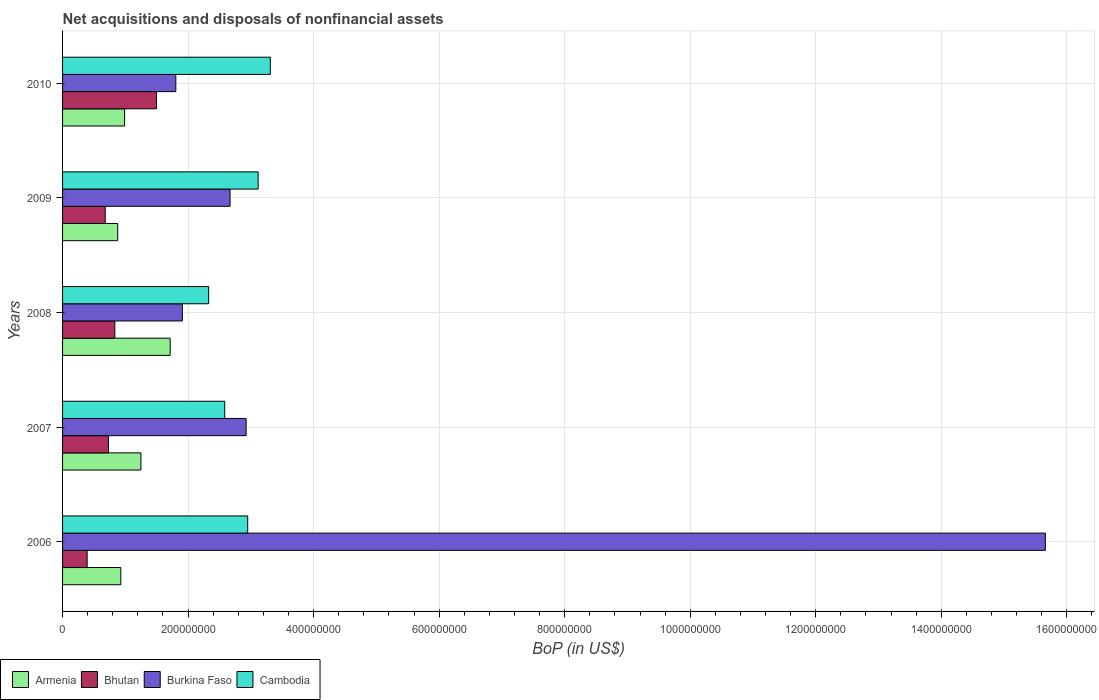How many groups of bars are there?
Make the answer very short. 5. Are the number of bars per tick equal to the number of legend labels?
Ensure brevity in your answer.  Yes. Are the number of bars on each tick of the Y-axis equal?
Provide a short and direct response. Yes. How many bars are there on the 4th tick from the bottom?
Your response must be concise. 4. What is the Balance of Payments in Cambodia in 2007?
Your response must be concise. 2.58e+08. Across all years, what is the maximum Balance of Payments in Bhutan?
Offer a very short reply. 1.50e+08. Across all years, what is the minimum Balance of Payments in Cambodia?
Provide a succinct answer. 2.33e+08. In which year was the Balance of Payments in Bhutan minimum?
Your answer should be very brief. 2006. What is the total Balance of Payments in Bhutan in the graph?
Give a very brief answer. 4.13e+08. What is the difference between the Balance of Payments in Burkina Faso in 2007 and that in 2010?
Your answer should be very brief. 1.12e+08. What is the difference between the Balance of Payments in Cambodia in 2006 and the Balance of Payments in Burkina Faso in 2008?
Offer a very short reply. 1.04e+08. What is the average Balance of Payments in Bhutan per year?
Provide a short and direct response. 8.26e+07. In the year 2010, what is the difference between the Balance of Payments in Burkina Faso and Balance of Payments in Cambodia?
Keep it short and to the point. -1.51e+08. What is the ratio of the Balance of Payments in Bhutan in 2008 to that in 2009?
Your response must be concise. 1.23. Is the difference between the Balance of Payments in Burkina Faso in 2006 and 2008 greater than the difference between the Balance of Payments in Cambodia in 2006 and 2008?
Make the answer very short. Yes. What is the difference between the highest and the second highest Balance of Payments in Armenia?
Provide a succinct answer. 4.66e+07. What is the difference between the highest and the lowest Balance of Payments in Bhutan?
Your response must be concise. 1.10e+08. In how many years, is the Balance of Payments in Cambodia greater than the average Balance of Payments in Cambodia taken over all years?
Provide a short and direct response. 3. Is the sum of the Balance of Payments in Bhutan in 2006 and 2009 greater than the maximum Balance of Payments in Cambodia across all years?
Make the answer very short. No. Is it the case that in every year, the sum of the Balance of Payments in Armenia and Balance of Payments in Cambodia is greater than the sum of Balance of Payments in Bhutan and Balance of Payments in Burkina Faso?
Make the answer very short. No. What does the 1st bar from the top in 2008 represents?
Give a very brief answer. Cambodia. What does the 2nd bar from the bottom in 2010 represents?
Your response must be concise. Bhutan. Is it the case that in every year, the sum of the Balance of Payments in Bhutan and Balance of Payments in Burkina Faso is greater than the Balance of Payments in Armenia?
Make the answer very short. Yes. Are all the bars in the graph horizontal?
Your answer should be compact. Yes. What is the difference between two consecutive major ticks on the X-axis?
Offer a very short reply. 2.00e+08. Does the graph contain grids?
Offer a terse response. Yes. How many legend labels are there?
Your answer should be compact. 4. What is the title of the graph?
Make the answer very short. Net acquisitions and disposals of nonfinancial assets. Does "Belgium" appear as one of the legend labels in the graph?
Provide a short and direct response. No. What is the label or title of the X-axis?
Your response must be concise. BoP (in US$). What is the BoP (in US$) of Armenia in 2006?
Give a very brief answer. 9.28e+07. What is the BoP (in US$) in Bhutan in 2006?
Your answer should be very brief. 3.91e+07. What is the BoP (in US$) of Burkina Faso in 2006?
Your answer should be compact. 1.57e+09. What is the BoP (in US$) of Cambodia in 2006?
Offer a terse response. 2.95e+08. What is the BoP (in US$) in Armenia in 2007?
Offer a very short reply. 1.25e+08. What is the BoP (in US$) of Bhutan in 2007?
Offer a terse response. 7.31e+07. What is the BoP (in US$) of Burkina Faso in 2007?
Provide a succinct answer. 2.92e+08. What is the BoP (in US$) in Cambodia in 2007?
Provide a short and direct response. 2.58e+08. What is the BoP (in US$) of Armenia in 2008?
Give a very brief answer. 1.71e+08. What is the BoP (in US$) of Bhutan in 2008?
Provide a succinct answer. 8.33e+07. What is the BoP (in US$) of Burkina Faso in 2008?
Ensure brevity in your answer.  1.91e+08. What is the BoP (in US$) of Cambodia in 2008?
Your answer should be very brief. 2.33e+08. What is the BoP (in US$) of Armenia in 2009?
Provide a succinct answer. 8.79e+07. What is the BoP (in US$) of Bhutan in 2009?
Offer a very short reply. 6.80e+07. What is the BoP (in US$) in Burkina Faso in 2009?
Your answer should be very brief. 2.67e+08. What is the BoP (in US$) in Cambodia in 2009?
Make the answer very short. 3.12e+08. What is the BoP (in US$) of Armenia in 2010?
Your answer should be very brief. 9.89e+07. What is the BoP (in US$) in Bhutan in 2010?
Your answer should be very brief. 1.50e+08. What is the BoP (in US$) of Burkina Faso in 2010?
Ensure brevity in your answer.  1.80e+08. What is the BoP (in US$) in Cambodia in 2010?
Your answer should be compact. 3.31e+08. Across all years, what is the maximum BoP (in US$) of Armenia?
Offer a very short reply. 1.71e+08. Across all years, what is the maximum BoP (in US$) of Bhutan?
Offer a terse response. 1.50e+08. Across all years, what is the maximum BoP (in US$) of Burkina Faso?
Offer a very short reply. 1.57e+09. Across all years, what is the maximum BoP (in US$) of Cambodia?
Give a very brief answer. 3.31e+08. Across all years, what is the minimum BoP (in US$) of Armenia?
Offer a terse response. 8.79e+07. Across all years, what is the minimum BoP (in US$) of Bhutan?
Keep it short and to the point. 3.91e+07. Across all years, what is the minimum BoP (in US$) of Burkina Faso?
Your response must be concise. 1.80e+08. Across all years, what is the minimum BoP (in US$) in Cambodia?
Your response must be concise. 2.33e+08. What is the total BoP (in US$) of Armenia in the graph?
Offer a very short reply. 5.76e+08. What is the total BoP (in US$) of Bhutan in the graph?
Give a very brief answer. 4.13e+08. What is the total BoP (in US$) in Burkina Faso in the graph?
Your answer should be compact. 2.50e+09. What is the total BoP (in US$) of Cambodia in the graph?
Provide a succinct answer. 1.43e+09. What is the difference between the BoP (in US$) in Armenia in 2006 and that in 2007?
Provide a short and direct response. -3.20e+07. What is the difference between the BoP (in US$) in Bhutan in 2006 and that in 2007?
Give a very brief answer. -3.40e+07. What is the difference between the BoP (in US$) of Burkina Faso in 2006 and that in 2007?
Provide a short and direct response. 1.27e+09. What is the difference between the BoP (in US$) in Cambodia in 2006 and that in 2007?
Your response must be concise. 3.66e+07. What is the difference between the BoP (in US$) of Armenia in 2006 and that in 2008?
Your answer should be very brief. -7.86e+07. What is the difference between the BoP (in US$) of Bhutan in 2006 and that in 2008?
Make the answer very short. -4.41e+07. What is the difference between the BoP (in US$) of Burkina Faso in 2006 and that in 2008?
Keep it short and to the point. 1.37e+09. What is the difference between the BoP (in US$) in Cambodia in 2006 and that in 2008?
Give a very brief answer. 6.22e+07. What is the difference between the BoP (in US$) of Armenia in 2006 and that in 2009?
Ensure brevity in your answer.  4.93e+06. What is the difference between the BoP (in US$) in Bhutan in 2006 and that in 2009?
Keep it short and to the point. -2.88e+07. What is the difference between the BoP (in US$) of Burkina Faso in 2006 and that in 2009?
Provide a succinct answer. 1.30e+09. What is the difference between the BoP (in US$) of Cambodia in 2006 and that in 2009?
Your answer should be compact. -1.66e+07. What is the difference between the BoP (in US$) in Armenia in 2006 and that in 2010?
Your answer should be compact. -6.05e+06. What is the difference between the BoP (in US$) of Bhutan in 2006 and that in 2010?
Ensure brevity in your answer.  -1.10e+08. What is the difference between the BoP (in US$) of Burkina Faso in 2006 and that in 2010?
Offer a terse response. 1.39e+09. What is the difference between the BoP (in US$) of Cambodia in 2006 and that in 2010?
Your answer should be very brief. -3.60e+07. What is the difference between the BoP (in US$) of Armenia in 2007 and that in 2008?
Give a very brief answer. -4.66e+07. What is the difference between the BoP (in US$) in Bhutan in 2007 and that in 2008?
Provide a succinct answer. -1.02e+07. What is the difference between the BoP (in US$) in Burkina Faso in 2007 and that in 2008?
Offer a terse response. 1.02e+08. What is the difference between the BoP (in US$) in Cambodia in 2007 and that in 2008?
Provide a short and direct response. 2.56e+07. What is the difference between the BoP (in US$) in Armenia in 2007 and that in 2009?
Ensure brevity in your answer.  3.70e+07. What is the difference between the BoP (in US$) in Bhutan in 2007 and that in 2009?
Ensure brevity in your answer.  5.15e+06. What is the difference between the BoP (in US$) of Burkina Faso in 2007 and that in 2009?
Your answer should be very brief. 2.56e+07. What is the difference between the BoP (in US$) in Cambodia in 2007 and that in 2009?
Your answer should be compact. -5.33e+07. What is the difference between the BoP (in US$) of Armenia in 2007 and that in 2010?
Your answer should be compact. 2.60e+07. What is the difference between the BoP (in US$) of Bhutan in 2007 and that in 2010?
Provide a short and direct response. -7.65e+07. What is the difference between the BoP (in US$) in Burkina Faso in 2007 and that in 2010?
Your answer should be very brief. 1.12e+08. What is the difference between the BoP (in US$) of Cambodia in 2007 and that in 2010?
Your answer should be very brief. -7.26e+07. What is the difference between the BoP (in US$) of Armenia in 2008 and that in 2009?
Keep it short and to the point. 8.36e+07. What is the difference between the BoP (in US$) of Bhutan in 2008 and that in 2009?
Give a very brief answer. 1.53e+07. What is the difference between the BoP (in US$) in Burkina Faso in 2008 and that in 2009?
Give a very brief answer. -7.60e+07. What is the difference between the BoP (in US$) in Cambodia in 2008 and that in 2009?
Your answer should be very brief. -7.89e+07. What is the difference between the BoP (in US$) in Armenia in 2008 and that in 2010?
Keep it short and to the point. 7.26e+07. What is the difference between the BoP (in US$) of Bhutan in 2008 and that in 2010?
Ensure brevity in your answer.  -6.64e+07. What is the difference between the BoP (in US$) in Burkina Faso in 2008 and that in 2010?
Make the answer very short. 1.05e+07. What is the difference between the BoP (in US$) of Cambodia in 2008 and that in 2010?
Make the answer very short. -9.82e+07. What is the difference between the BoP (in US$) in Armenia in 2009 and that in 2010?
Offer a terse response. -1.10e+07. What is the difference between the BoP (in US$) in Bhutan in 2009 and that in 2010?
Offer a very short reply. -8.17e+07. What is the difference between the BoP (in US$) of Burkina Faso in 2009 and that in 2010?
Give a very brief answer. 8.64e+07. What is the difference between the BoP (in US$) of Cambodia in 2009 and that in 2010?
Your response must be concise. -1.94e+07. What is the difference between the BoP (in US$) in Armenia in 2006 and the BoP (in US$) in Bhutan in 2007?
Give a very brief answer. 1.97e+07. What is the difference between the BoP (in US$) in Armenia in 2006 and the BoP (in US$) in Burkina Faso in 2007?
Your response must be concise. -2.00e+08. What is the difference between the BoP (in US$) of Armenia in 2006 and the BoP (in US$) of Cambodia in 2007?
Your answer should be compact. -1.66e+08. What is the difference between the BoP (in US$) in Bhutan in 2006 and the BoP (in US$) in Burkina Faso in 2007?
Provide a succinct answer. -2.53e+08. What is the difference between the BoP (in US$) of Bhutan in 2006 and the BoP (in US$) of Cambodia in 2007?
Keep it short and to the point. -2.19e+08. What is the difference between the BoP (in US$) in Burkina Faso in 2006 and the BoP (in US$) in Cambodia in 2007?
Provide a short and direct response. 1.31e+09. What is the difference between the BoP (in US$) of Armenia in 2006 and the BoP (in US$) of Bhutan in 2008?
Your answer should be compact. 9.53e+06. What is the difference between the BoP (in US$) of Armenia in 2006 and the BoP (in US$) of Burkina Faso in 2008?
Your response must be concise. -9.81e+07. What is the difference between the BoP (in US$) in Armenia in 2006 and the BoP (in US$) in Cambodia in 2008?
Ensure brevity in your answer.  -1.40e+08. What is the difference between the BoP (in US$) of Bhutan in 2006 and the BoP (in US$) of Burkina Faso in 2008?
Keep it short and to the point. -1.52e+08. What is the difference between the BoP (in US$) of Bhutan in 2006 and the BoP (in US$) of Cambodia in 2008?
Keep it short and to the point. -1.94e+08. What is the difference between the BoP (in US$) in Burkina Faso in 2006 and the BoP (in US$) in Cambodia in 2008?
Provide a succinct answer. 1.33e+09. What is the difference between the BoP (in US$) of Armenia in 2006 and the BoP (in US$) of Bhutan in 2009?
Your answer should be very brief. 2.48e+07. What is the difference between the BoP (in US$) of Armenia in 2006 and the BoP (in US$) of Burkina Faso in 2009?
Offer a terse response. -1.74e+08. What is the difference between the BoP (in US$) of Armenia in 2006 and the BoP (in US$) of Cambodia in 2009?
Your answer should be compact. -2.19e+08. What is the difference between the BoP (in US$) of Bhutan in 2006 and the BoP (in US$) of Burkina Faso in 2009?
Provide a short and direct response. -2.28e+08. What is the difference between the BoP (in US$) in Bhutan in 2006 and the BoP (in US$) in Cambodia in 2009?
Give a very brief answer. -2.72e+08. What is the difference between the BoP (in US$) in Burkina Faso in 2006 and the BoP (in US$) in Cambodia in 2009?
Ensure brevity in your answer.  1.25e+09. What is the difference between the BoP (in US$) of Armenia in 2006 and the BoP (in US$) of Bhutan in 2010?
Your answer should be compact. -5.68e+07. What is the difference between the BoP (in US$) in Armenia in 2006 and the BoP (in US$) in Burkina Faso in 2010?
Offer a terse response. -8.76e+07. What is the difference between the BoP (in US$) of Armenia in 2006 and the BoP (in US$) of Cambodia in 2010?
Make the answer very short. -2.38e+08. What is the difference between the BoP (in US$) in Bhutan in 2006 and the BoP (in US$) in Burkina Faso in 2010?
Your response must be concise. -1.41e+08. What is the difference between the BoP (in US$) in Bhutan in 2006 and the BoP (in US$) in Cambodia in 2010?
Ensure brevity in your answer.  -2.92e+08. What is the difference between the BoP (in US$) of Burkina Faso in 2006 and the BoP (in US$) of Cambodia in 2010?
Ensure brevity in your answer.  1.23e+09. What is the difference between the BoP (in US$) of Armenia in 2007 and the BoP (in US$) of Bhutan in 2008?
Provide a short and direct response. 4.15e+07. What is the difference between the BoP (in US$) of Armenia in 2007 and the BoP (in US$) of Burkina Faso in 2008?
Your answer should be very brief. -6.60e+07. What is the difference between the BoP (in US$) in Armenia in 2007 and the BoP (in US$) in Cambodia in 2008?
Offer a terse response. -1.08e+08. What is the difference between the BoP (in US$) in Bhutan in 2007 and the BoP (in US$) in Burkina Faso in 2008?
Offer a very short reply. -1.18e+08. What is the difference between the BoP (in US$) in Bhutan in 2007 and the BoP (in US$) in Cambodia in 2008?
Provide a short and direct response. -1.60e+08. What is the difference between the BoP (in US$) in Burkina Faso in 2007 and the BoP (in US$) in Cambodia in 2008?
Provide a short and direct response. 5.97e+07. What is the difference between the BoP (in US$) of Armenia in 2007 and the BoP (in US$) of Bhutan in 2009?
Your answer should be compact. 5.68e+07. What is the difference between the BoP (in US$) in Armenia in 2007 and the BoP (in US$) in Burkina Faso in 2009?
Provide a short and direct response. -1.42e+08. What is the difference between the BoP (in US$) of Armenia in 2007 and the BoP (in US$) of Cambodia in 2009?
Your answer should be compact. -1.87e+08. What is the difference between the BoP (in US$) in Bhutan in 2007 and the BoP (in US$) in Burkina Faso in 2009?
Give a very brief answer. -1.94e+08. What is the difference between the BoP (in US$) in Bhutan in 2007 and the BoP (in US$) in Cambodia in 2009?
Make the answer very short. -2.38e+08. What is the difference between the BoP (in US$) of Burkina Faso in 2007 and the BoP (in US$) of Cambodia in 2009?
Provide a short and direct response. -1.91e+07. What is the difference between the BoP (in US$) in Armenia in 2007 and the BoP (in US$) in Bhutan in 2010?
Give a very brief answer. -2.48e+07. What is the difference between the BoP (in US$) of Armenia in 2007 and the BoP (in US$) of Burkina Faso in 2010?
Ensure brevity in your answer.  -5.56e+07. What is the difference between the BoP (in US$) of Armenia in 2007 and the BoP (in US$) of Cambodia in 2010?
Ensure brevity in your answer.  -2.06e+08. What is the difference between the BoP (in US$) of Bhutan in 2007 and the BoP (in US$) of Burkina Faso in 2010?
Give a very brief answer. -1.07e+08. What is the difference between the BoP (in US$) of Bhutan in 2007 and the BoP (in US$) of Cambodia in 2010?
Your answer should be compact. -2.58e+08. What is the difference between the BoP (in US$) of Burkina Faso in 2007 and the BoP (in US$) of Cambodia in 2010?
Your answer should be very brief. -3.85e+07. What is the difference between the BoP (in US$) in Armenia in 2008 and the BoP (in US$) in Bhutan in 2009?
Make the answer very short. 1.03e+08. What is the difference between the BoP (in US$) of Armenia in 2008 and the BoP (in US$) of Burkina Faso in 2009?
Provide a succinct answer. -9.54e+07. What is the difference between the BoP (in US$) of Armenia in 2008 and the BoP (in US$) of Cambodia in 2009?
Make the answer very short. -1.40e+08. What is the difference between the BoP (in US$) of Bhutan in 2008 and the BoP (in US$) of Burkina Faso in 2009?
Make the answer very short. -1.84e+08. What is the difference between the BoP (in US$) in Bhutan in 2008 and the BoP (in US$) in Cambodia in 2009?
Give a very brief answer. -2.28e+08. What is the difference between the BoP (in US$) in Burkina Faso in 2008 and the BoP (in US$) in Cambodia in 2009?
Give a very brief answer. -1.21e+08. What is the difference between the BoP (in US$) in Armenia in 2008 and the BoP (in US$) in Bhutan in 2010?
Your response must be concise. 2.18e+07. What is the difference between the BoP (in US$) of Armenia in 2008 and the BoP (in US$) of Burkina Faso in 2010?
Make the answer very short. -8.98e+06. What is the difference between the BoP (in US$) in Armenia in 2008 and the BoP (in US$) in Cambodia in 2010?
Your response must be concise. -1.60e+08. What is the difference between the BoP (in US$) in Bhutan in 2008 and the BoP (in US$) in Burkina Faso in 2010?
Offer a very short reply. -9.71e+07. What is the difference between the BoP (in US$) of Bhutan in 2008 and the BoP (in US$) of Cambodia in 2010?
Your answer should be very brief. -2.48e+08. What is the difference between the BoP (in US$) of Burkina Faso in 2008 and the BoP (in US$) of Cambodia in 2010?
Provide a short and direct response. -1.40e+08. What is the difference between the BoP (in US$) of Armenia in 2009 and the BoP (in US$) of Bhutan in 2010?
Make the answer very short. -6.18e+07. What is the difference between the BoP (in US$) of Armenia in 2009 and the BoP (in US$) of Burkina Faso in 2010?
Your answer should be compact. -9.25e+07. What is the difference between the BoP (in US$) in Armenia in 2009 and the BoP (in US$) in Cambodia in 2010?
Ensure brevity in your answer.  -2.43e+08. What is the difference between the BoP (in US$) in Bhutan in 2009 and the BoP (in US$) in Burkina Faso in 2010?
Offer a terse response. -1.12e+08. What is the difference between the BoP (in US$) of Bhutan in 2009 and the BoP (in US$) of Cambodia in 2010?
Keep it short and to the point. -2.63e+08. What is the difference between the BoP (in US$) in Burkina Faso in 2009 and the BoP (in US$) in Cambodia in 2010?
Offer a terse response. -6.41e+07. What is the average BoP (in US$) of Armenia per year?
Give a very brief answer. 1.15e+08. What is the average BoP (in US$) in Bhutan per year?
Give a very brief answer. 8.26e+07. What is the average BoP (in US$) in Burkina Faso per year?
Provide a succinct answer. 4.99e+08. What is the average BoP (in US$) in Cambodia per year?
Keep it short and to the point. 2.86e+08. In the year 2006, what is the difference between the BoP (in US$) of Armenia and BoP (in US$) of Bhutan?
Give a very brief answer. 5.37e+07. In the year 2006, what is the difference between the BoP (in US$) of Armenia and BoP (in US$) of Burkina Faso?
Give a very brief answer. -1.47e+09. In the year 2006, what is the difference between the BoP (in US$) in Armenia and BoP (in US$) in Cambodia?
Give a very brief answer. -2.02e+08. In the year 2006, what is the difference between the BoP (in US$) in Bhutan and BoP (in US$) in Burkina Faso?
Your answer should be compact. -1.53e+09. In the year 2006, what is the difference between the BoP (in US$) of Bhutan and BoP (in US$) of Cambodia?
Ensure brevity in your answer.  -2.56e+08. In the year 2006, what is the difference between the BoP (in US$) in Burkina Faso and BoP (in US$) in Cambodia?
Ensure brevity in your answer.  1.27e+09. In the year 2007, what is the difference between the BoP (in US$) in Armenia and BoP (in US$) in Bhutan?
Give a very brief answer. 5.17e+07. In the year 2007, what is the difference between the BoP (in US$) of Armenia and BoP (in US$) of Burkina Faso?
Your answer should be compact. -1.68e+08. In the year 2007, what is the difference between the BoP (in US$) of Armenia and BoP (in US$) of Cambodia?
Keep it short and to the point. -1.34e+08. In the year 2007, what is the difference between the BoP (in US$) of Bhutan and BoP (in US$) of Burkina Faso?
Provide a succinct answer. -2.19e+08. In the year 2007, what is the difference between the BoP (in US$) in Bhutan and BoP (in US$) in Cambodia?
Give a very brief answer. -1.85e+08. In the year 2007, what is the difference between the BoP (in US$) in Burkina Faso and BoP (in US$) in Cambodia?
Keep it short and to the point. 3.41e+07. In the year 2008, what is the difference between the BoP (in US$) of Armenia and BoP (in US$) of Bhutan?
Give a very brief answer. 8.81e+07. In the year 2008, what is the difference between the BoP (in US$) in Armenia and BoP (in US$) in Burkina Faso?
Keep it short and to the point. -1.94e+07. In the year 2008, what is the difference between the BoP (in US$) in Armenia and BoP (in US$) in Cambodia?
Offer a very short reply. -6.13e+07. In the year 2008, what is the difference between the BoP (in US$) of Bhutan and BoP (in US$) of Burkina Faso?
Provide a succinct answer. -1.08e+08. In the year 2008, what is the difference between the BoP (in US$) of Bhutan and BoP (in US$) of Cambodia?
Your answer should be compact. -1.49e+08. In the year 2008, what is the difference between the BoP (in US$) in Burkina Faso and BoP (in US$) in Cambodia?
Your answer should be very brief. -4.19e+07. In the year 2009, what is the difference between the BoP (in US$) of Armenia and BoP (in US$) of Bhutan?
Ensure brevity in your answer.  1.99e+07. In the year 2009, what is the difference between the BoP (in US$) of Armenia and BoP (in US$) of Burkina Faso?
Keep it short and to the point. -1.79e+08. In the year 2009, what is the difference between the BoP (in US$) in Armenia and BoP (in US$) in Cambodia?
Your answer should be compact. -2.24e+08. In the year 2009, what is the difference between the BoP (in US$) in Bhutan and BoP (in US$) in Burkina Faso?
Provide a succinct answer. -1.99e+08. In the year 2009, what is the difference between the BoP (in US$) in Bhutan and BoP (in US$) in Cambodia?
Your answer should be very brief. -2.44e+08. In the year 2009, what is the difference between the BoP (in US$) of Burkina Faso and BoP (in US$) of Cambodia?
Make the answer very short. -4.47e+07. In the year 2010, what is the difference between the BoP (in US$) in Armenia and BoP (in US$) in Bhutan?
Your answer should be compact. -5.08e+07. In the year 2010, what is the difference between the BoP (in US$) in Armenia and BoP (in US$) in Burkina Faso?
Your answer should be compact. -8.16e+07. In the year 2010, what is the difference between the BoP (in US$) in Armenia and BoP (in US$) in Cambodia?
Your answer should be compact. -2.32e+08. In the year 2010, what is the difference between the BoP (in US$) in Bhutan and BoP (in US$) in Burkina Faso?
Make the answer very short. -3.08e+07. In the year 2010, what is the difference between the BoP (in US$) in Bhutan and BoP (in US$) in Cambodia?
Offer a very short reply. -1.81e+08. In the year 2010, what is the difference between the BoP (in US$) of Burkina Faso and BoP (in US$) of Cambodia?
Your answer should be compact. -1.51e+08. What is the ratio of the BoP (in US$) in Armenia in 2006 to that in 2007?
Give a very brief answer. 0.74. What is the ratio of the BoP (in US$) of Bhutan in 2006 to that in 2007?
Keep it short and to the point. 0.54. What is the ratio of the BoP (in US$) in Burkina Faso in 2006 to that in 2007?
Your answer should be compact. 5.35. What is the ratio of the BoP (in US$) of Cambodia in 2006 to that in 2007?
Ensure brevity in your answer.  1.14. What is the ratio of the BoP (in US$) in Armenia in 2006 to that in 2008?
Your answer should be very brief. 0.54. What is the ratio of the BoP (in US$) of Bhutan in 2006 to that in 2008?
Ensure brevity in your answer.  0.47. What is the ratio of the BoP (in US$) of Burkina Faso in 2006 to that in 2008?
Keep it short and to the point. 8.2. What is the ratio of the BoP (in US$) of Cambodia in 2006 to that in 2008?
Provide a short and direct response. 1.27. What is the ratio of the BoP (in US$) in Armenia in 2006 to that in 2009?
Provide a short and direct response. 1.06. What is the ratio of the BoP (in US$) of Bhutan in 2006 to that in 2009?
Offer a terse response. 0.58. What is the ratio of the BoP (in US$) in Burkina Faso in 2006 to that in 2009?
Offer a terse response. 5.87. What is the ratio of the BoP (in US$) in Cambodia in 2006 to that in 2009?
Your answer should be very brief. 0.95. What is the ratio of the BoP (in US$) in Armenia in 2006 to that in 2010?
Ensure brevity in your answer.  0.94. What is the ratio of the BoP (in US$) in Bhutan in 2006 to that in 2010?
Your answer should be very brief. 0.26. What is the ratio of the BoP (in US$) of Burkina Faso in 2006 to that in 2010?
Make the answer very short. 8.68. What is the ratio of the BoP (in US$) of Cambodia in 2006 to that in 2010?
Give a very brief answer. 0.89. What is the ratio of the BoP (in US$) in Armenia in 2007 to that in 2008?
Your response must be concise. 0.73. What is the ratio of the BoP (in US$) in Bhutan in 2007 to that in 2008?
Your answer should be compact. 0.88. What is the ratio of the BoP (in US$) in Burkina Faso in 2007 to that in 2008?
Provide a short and direct response. 1.53. What is the ratio of the BoP (in US$) in Cambodia in 2007 to that in 2008?
Your answer should be compact. 1.11. What is the ratio of the BoP (in US$) of Armenia in 2007 to that in 2009?
Make the answer very short. 1.42. What is the ratio of the BoP (in US$) in Bhutan in 2007 to that in 2009?
Offer a terse response. 1.08. What is the ratio of the BoP (in US$) in Burkina Faso in 2007 to that in 2009?
Your response must be concise. 1.1. What is the ratio of the BoP (in US$) of Cambodia in 2007 to that in 2009?
Keep it short and to the point. 0.83. What is the ratio of the BoP (in US$) in Armenia in 2007 to that in 2010?
Your answer should be very brief. 1.26. What is the ratio of the BoP (in US$) of Bhutan in 2007 to that in 2010?
Your answer should be very brief. 0.49. What is the ratio of the BoP (in US$) in Burkina Faso in 2007 to that in 2010?
Keep it short and to the point. 1.62. What is the ratio of the BoP (in US$) in Cambodia in 2007 to that in 2010?
Offer a terse response. 0.78. What is the ratio of the BoP (in US$) of Armenia in 2008 to that in 2009?
Provide a succinct answer. 1.95. What is the ratio of the BoP (in US$) in Bhutan in 2008 to that in 2009?
Keep it short and to the point. 1.23. What is the ratio of the BoP (in US$) of Burkina Faso in 2008 to that in 2009?
Offer a very short reply. 0.72. What is the ratio of the BoP (in US$) of Cambodia in 2008 to that in 2009?
Make the answer very short. 0.75. What is the ratio of the BoP (in US$) of Armenia in 2008 to that in 2010?
Keep it short and to the point. 1.73. What is the ratio of the BoP (in US$) in Bhutan in 2008 to that in 2010?
Your answer should be compact. 0.56. What is the ratio of the BoP (in US$) of Burkina Faso in 2008 to that in 2010?
Keep it short and to the point. 1.06. What is the ratio of the BoP (in US$) in Cambodia in 2008 to that in 2010?
Offer a terse response. 0.7. What is the ratio of the BoP (in US$) in Bhutan in 2009 to that in 2010?
Provide a short and direct response. 0.45. What is the ratio of the BoP (in US$) of Burkina Faso in 2009 to that in 2010?
Offer a very short reply. 1.48. What is the ratio of the BoP (in US$) of Cambodia in 2009 to that in 2010?
Make the answer very short. 0.94. What is the difference between the highest and the second highest BoP (in US$) in Armenia?
Make the answer very short. 4.66e+07. What is the difference between the highest and the second highest BoP (in US$) of Bhutan?
Your response must be concise. 6.64e+07. What is the difference between the highest and the second highest BoP (in US$) in Burkina Faso?
Provide a short and direct response. 1.27e+09. What is the difference between the highest and the second highest BoP (in US$) of Cambodia?
Keep it short and to the point. 1.94e+07. What is the difference between the highest and the lowest BoP (in US$) of Armenia?
Your answer should be compact. 8.36e+07. What is the difference between the highest and the lowest BoP (in US$) of Bhutan?
Give a very brief answer. 1.10e+08. What is the difference between the highest and the lowest BoP (in US$) in Burkina Faso?
Your answer should be compact. 1.39e+09. What is the difference between the highest and the lowest BoP (in US$) of Cambodia?
Provide a short and direct response. 9.82e+07. 